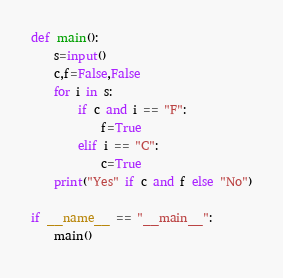<code> <loc_0><loc_0><loc_500><loc_500><_Python_>def main():
    s=input()
    c,f=False,False
    for i in s:
        if c and i == "F":
            f=True
        elif i == "C":
            c=True
    print("Yes" if c and f else "No")
    
if __name__ == "__main__":
    main()</code> 